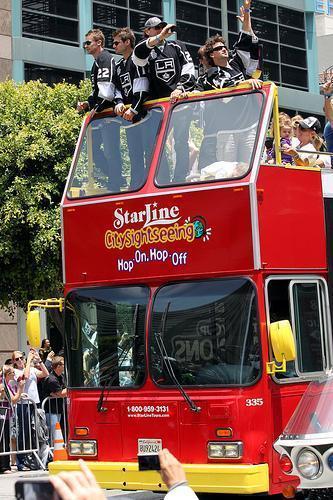How many headlights are on the front of the bus?
Give a very brief answer. 2. 